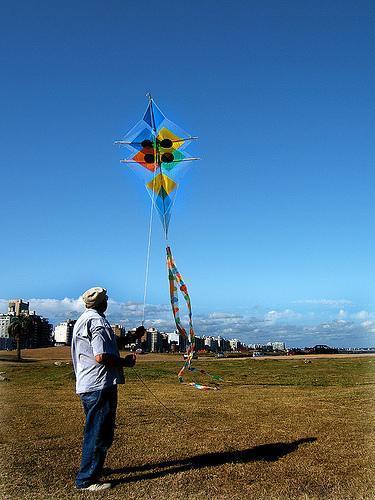How many people are pictured?
Give a very brief answer. 1. How many little girls are flying kites?
Give a very brief answer. 0. 